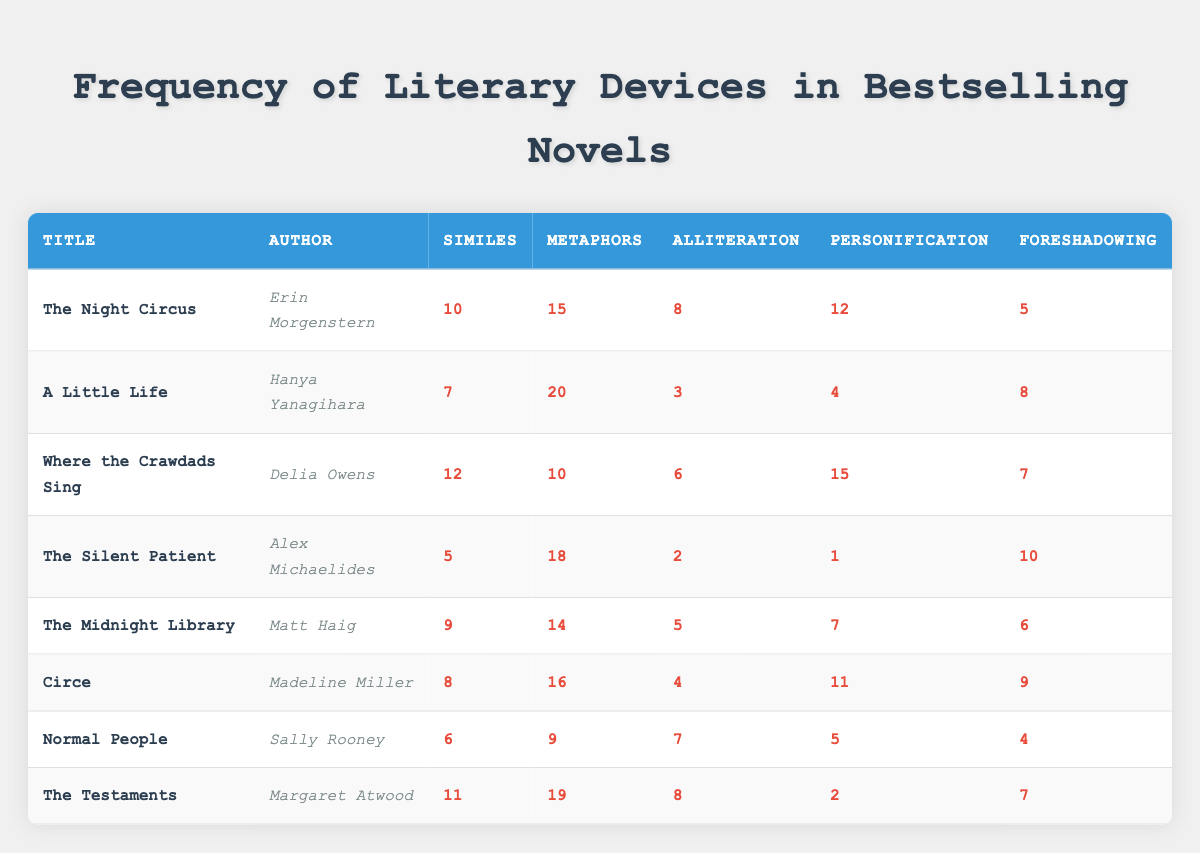What is the highest number of metaphors used in a single novel? Looking at the column for metaphors, the highest value is 20, found in "A Little Life" by Hanya Yanagihara.
Answer: 20 Which novel features the least number of personifications? In the personification column, the lowest count is 1, which is for "The Silent Patient" by Alex Michaelides.
Answer: The Silent Patient How many similes are there in "Where the Crawdads Sing"? The table shows that "Where the Crawdads Sing" has 12 similes listed in the corresponding cell.
Answer: 12 What is the total number of alliterations across all novels? To find the total alliterations, you add each count: 8 + 3 + 6 + 2 + 5 + 4 + 7 + 8 = 43.
Answer: 43 Which author has the highest overall count of literary devices combined? Summing up the counts for all devices for each author shows that Hanya Yanagihara has 20 + 7 + 3 + 4 + 8 = 42, which is the highest total.
Answer: Hanya Yanagihara Did "The Midnight Library" use more similes than "Normal People"? Checking the table, "The Midnight Library" has 9 similes while "Normal People" has 6, confirming that it used more.
Answer: Yes What percentage of novels used more than 10 similes? There are 8 novels, and 4 of them have more than 10 similes ("The Night Circus," "Where the Crawdads Sing," "The Testaments," "The Midnight Library"). Thus, 4 out of 8 equals 50%.
Answer: 50% Is there a novel that uses more than 15 foreshadowing instances? Looking at the foreshadowing counts, no novel exceeds 15, as the highest is 10 (in "The Silent Patient").
Answer: No Which literary device is most prevalent in "Circe"? Analyzing the counts, "Circe" has 16 metaphors which is the highest among its counts of other literary devices.
Answer: Metaphors 